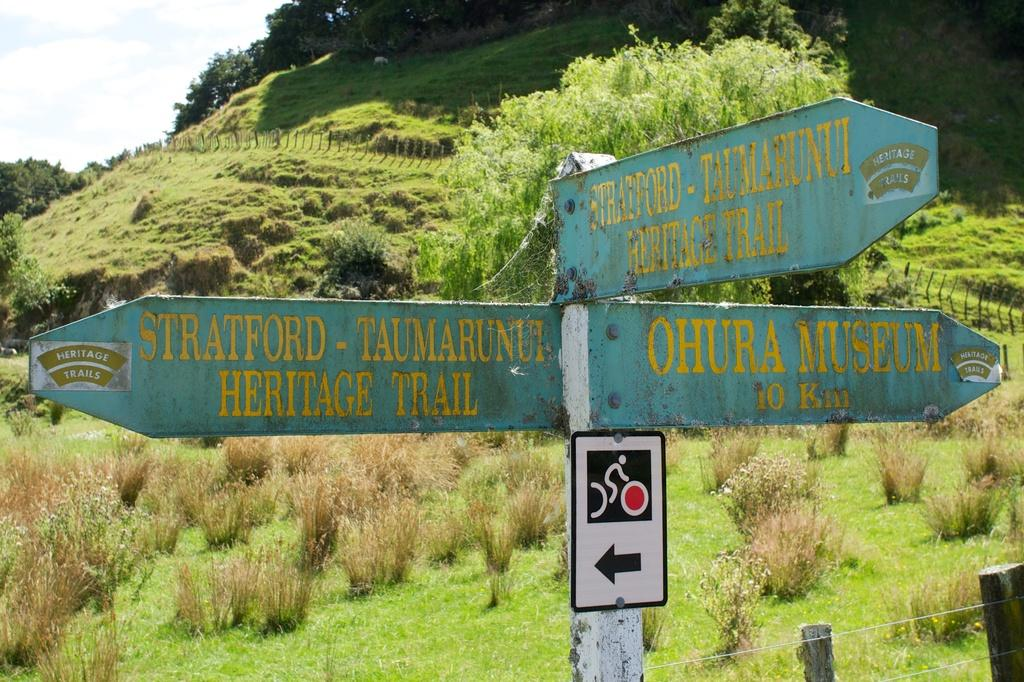<image>
Provide a brief description of the given image. A bank of directional signs shows the way to the Ohura Museum is to the right. 